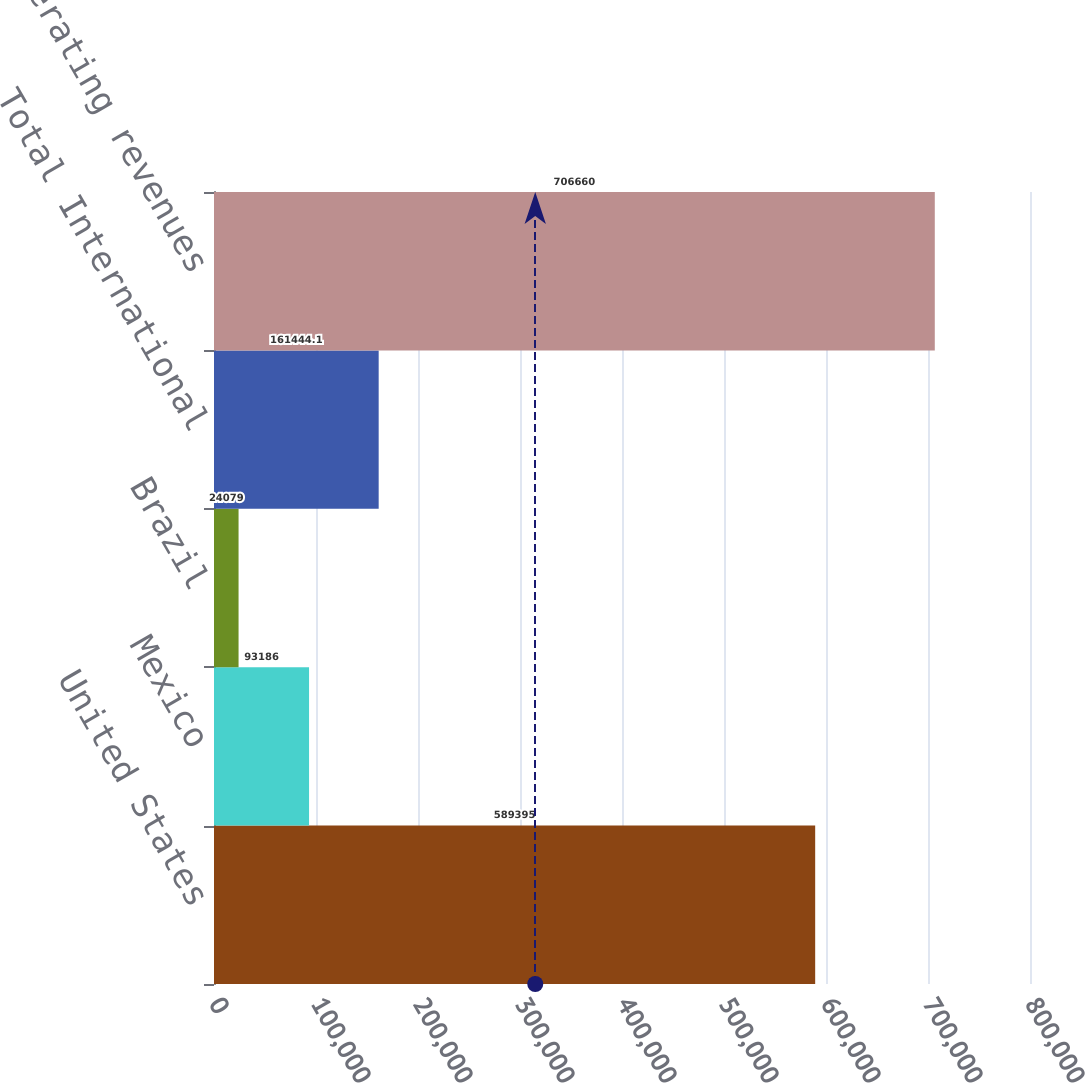<chart> <loc_0><loc_0><loc_500><loc_500><bar_chart><fcel>United States<fcel>Mexico<fcel>Brazil<fcel>Total International<fcel>Total operating revenues<nl><fcel>589395<fcel>93186<fcel>24079<fcel>161444<fcel>706660<nl></chart> 